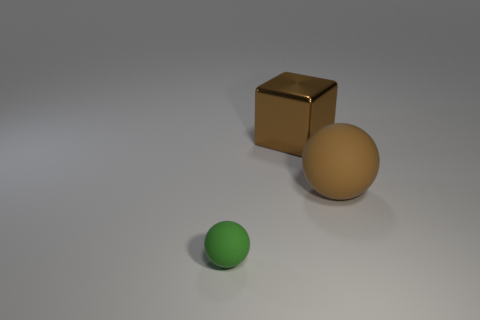Add 2 large brown metal things. How many objects exist? 5 Subtract all balls. How many objects are left? 1 Add 1 large rubber spheres. How many large rubber spheres exist? 2 Subtract 1 green balls. How many objects are left? 2 Subtract all big matte blocks. Subtract all big brown rubber spheres. How many objects are left? 2 Add 2 small spheres. How many small spheres are left? 3 